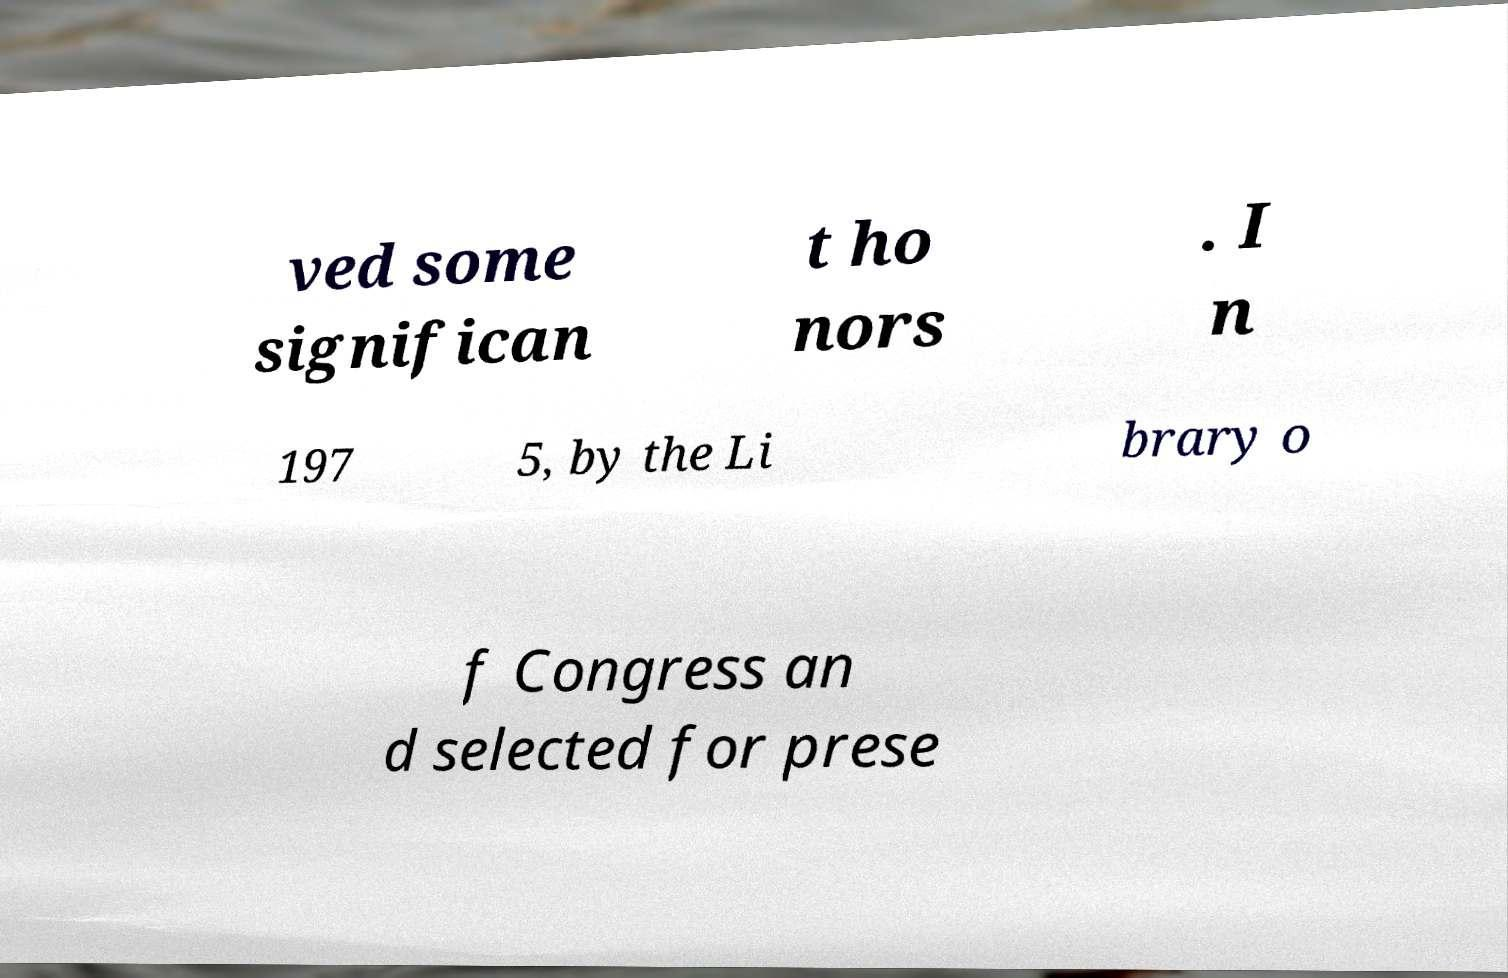I need the written content from this picture converted into text. Can you do that? ved some significan t ho nors . I n 197 5, by the Li brary o f Congress an d selected for prese 